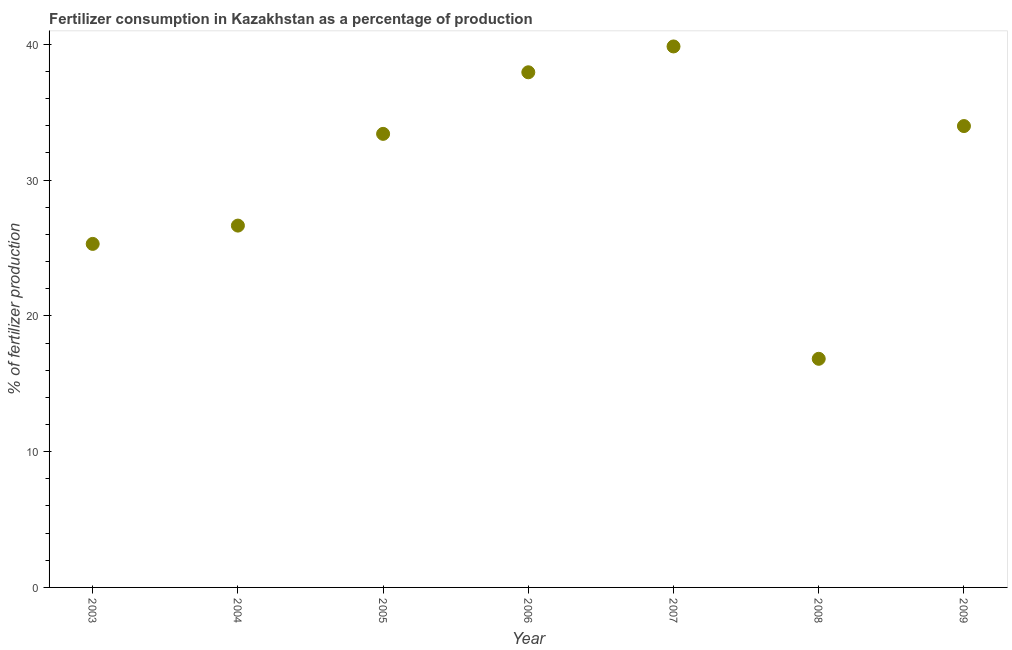What is the amount of fertilizer consumption in 2005?
Make the answer very short. 33.4. Across all years, what is the maximum amount of fertilizer consumption?
Ensure brevity in your answer.  39.84. Across all years, what is the minimum amount of fertilizer consumption?
Make the answer very short. 16.84. In which year was the amount of fertilizer consumption minimum?
Your answer should be compact. 2008. What is the sum of the amount of fertilizer consumption?
Provide a short and direct response. 213.93. What is the difference between the amount of fertilizer consumption in 2003 and 2006?
Make the answer very short. -12.64. What is the average amount of fertilizer consumption per year?
Your answer should be very brief. 30.56. What is the median amount of fertilizer consumption?
Make the answer very short. 33.4. Do a majority of the years between 2008 and 2005 (inclusive) have amount of fertilizer consumption greater than 26 %?
Make the answer very short. Yes. What is the ratio of the amount of fertilizer consumption in 2005 to that in 2006?
Give a very brief answer. 0.88. Is the difference between the amount of fertilizer consumption in 2006 and 2009 greater than the difference between any two years?
Your answer should be compact. No. What is the difference between the highest and the second highest amount of fertilizer consumption?
Offer a terse response. 1.9. Is the sum of the amount of fertilizer consumption in 2003 and 2006 greater than the maximum amount of fertilizer consumption across all years?
Provide a short and direct response. Yes. What is the difference between the highest and the lowest amount of fertilizer consumption?
Offer a very short reply. 23. In how many years, is the amount of fertilizer consumption greater than the average amount of fertilizer consumption taken over all years?
Offer a terse response. 4. How many dotlines are there?
Provide a short and direct response. 1. How many years are there in the graph?
Give a very brief answer. 7. Does the graph contain any zero values?
Ensure brevity in your answer.  No. Does the graph contain grids?
Ensure brevity in your answer.  No. What is the title of the graph?
Offer a very short reply. Fertilizer consumption in Kazakhstan as a percentage of production. What is the label or title of the X-axis?
Give a very brief answer. Year. What is the label or title of the Y-axis?
Ensure brevity in your answer.  % of fertilizer production. What is the % of fertilizer production in 2003?
Give a very brief answer. 25.3. What is the % of fertilizer production in 2004?
Provide a short and direct response. 26.65. What is the % of fertilizer production in 2005?
Make the answer very short. 33.4. What is the % of fertilizer production in 2006?
Give a very brief answer. 37.94. What is the % of fertilizer production in 2007?
Give a very brief answer. 39.84. What is the % of fertilizer production in 2008?
Offer a terse response. 16.84. What is the % of fertilizer production in 2009?
Your response must be concise. 33.98. What is the difference between the % of fertilizer production in 2003 and 2004?
Make the answer very short. -1.35. What is the difference between the % of fertilizer production in 2003 and 2005?
Offer a very short reply. -8.1. What is the difference between the % of fertilizer production in 2003 and 2006?
Keep it short and to the point. -12.64. What is the difference between the % of fertilizer production in 2003 and 2007?
Give a very brief answer. -14.54. What is the difference between the % of fertilizer production in 2003 and 2008?
Provide a succinct answer. 8.46. What is the difference between the % of fertilizer production in 2003 and 2009?
Provide a short and direct response. -8.68. What is the difference between the % of fertilizer production in 2004 and 2005?
Your answer should be very brief. -6.76. What is the difference between the % of fertilizer production in 2004 and 2006?
Provide a short and direct response. -11.29. What is the difference between the % of fertilizer production in 2004 and 2007?
Provide a succinct answer. -13.19. What is the difference between the % of fertilizer production in 2004 and 2008?
Offer a terse response. 9.81. What is the difference between the % of fertilizer production in 2004 and 2009?
Your answer should be compact. -7.33. What is the difference between the % of fertilizer production in 2005 and 2006?
Make the answer very short. -4.54. What is the difference between the % of fertilizer production in 2005 and 2007?
Make the answer very short. -6.44. What is the difference between the % of fertilizer production in 2005 and 2008?
Make the answer very short. 16.56. What is the difference between the % of fertilizer production in 2005 and 2009?
Keep it short and to the point. -0.57. What is the difference between the % of fertilizer production in 2006 and 2007?
Your answer should be compact. -1.9. What is the difference between the % of fertilizer production in 2006 and 2008?
Your answer should be very brief. 21.1. What is the difference between the % of fertilizer production in 2006 and 2009?
Provide a short and direct response. 3.96. What is the difference between the % of fertilizer production in 2007 and 2008?
Your answer should be very brief. 23. What is the difference between the % of fertilizer production in 2007 and 2009?
Provide a short and direct response. 5.86. What is the difference between the % of fertilizer production in 2008 and 2009?
Provide a short and direct response. -17.14. What is the ratio of the % of fertilizer production in 2003 to that in 2004?
Give a very brief answer. 0.95. What is the ratio of the % of fertilizer production in 2003 to that in 2005?
Give a very brief answer. 0.76. What is the ratio of the % of fertilizer production in 2003 to that in 2006?
Provide a succinct answer. 0.67. What is the ratio of the % of fertilizer production in 2003 to that in 2007?
Your answer should be very brief. 0.64. What is the ratio of the % of fertilizer production in 2003 to that in 2008?
Your answer should be very brief. 1.5. What is the ratio of the % of fertilizer production in 2003 to that in 2009?
Offer a terse response. 0.74. What is the ratio of the % of fertilizer production in 2004 to that in 2005?
Provide a succinct answer. 0.8. What is the ratio of the % of fertilizer production in 2004 to that in 2006?
Your answer should be very brief. 0.7. What is the ratio of the % of fertilizer production in 2004 to that in 2007?
Offer a terse response. 0.67. What is the ratio of the % of fertilizer production in 2004 to that in 2008?
Offer a very short reply. 1.58. What is the ratio of the % of fertilizer production in 2004 to that in 2009?
Give a very brief answer. 0.78. What is the ratio of the % of fertilizer production in 2005 to that in 2007?
Your answer should be compact. 0.84. What is the ratio of the % of fertilizer production in 2005 to that in 2008?
Keep it short and to the point. 1.98. What is the ratio of the % of fertilizer production in 2006 to that in 2007?
Your answer should be compact. 0.95. What is the ratio of the % of fertilizer production in 2006 to that in 2008?
Provide a short and direct response. 2.25. What is the ratio of the % of fertilizer production in 2006 to that in 2009?
Give a very brief answer. 1.12. What is the ratio of the % of fertilizer production in 2007 to that in 2008?
Provide a succinct answer. 2.37. What is the ratio of the % of fertilizer production in 2007 to that in 2009?
Offer a very short reply. 1.17. What is the ratio of the % of fertilizer production in 2008 to that in 2009?
Your answer should be compact. 0.5. 